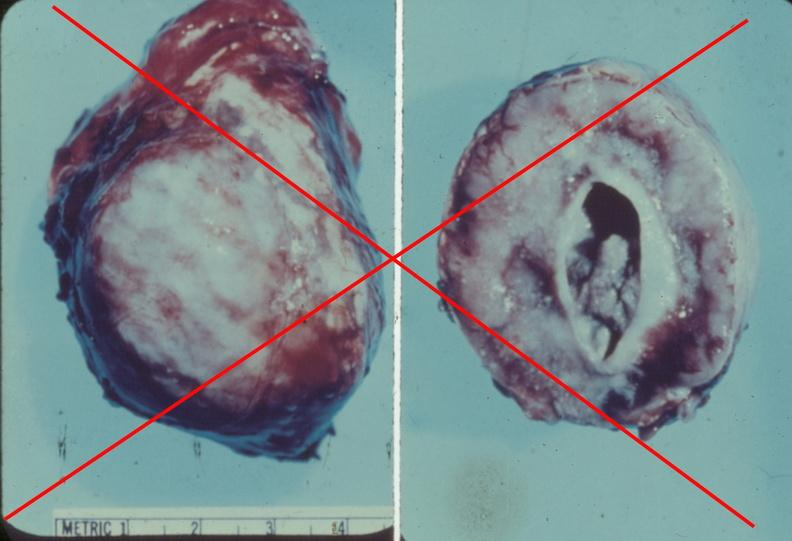where does this belong to?
Answer the question using a single word or phrase. Endocrine system 